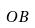<formula> <loc_0><loc_0><loc_500><loc_500>O B</formula> 